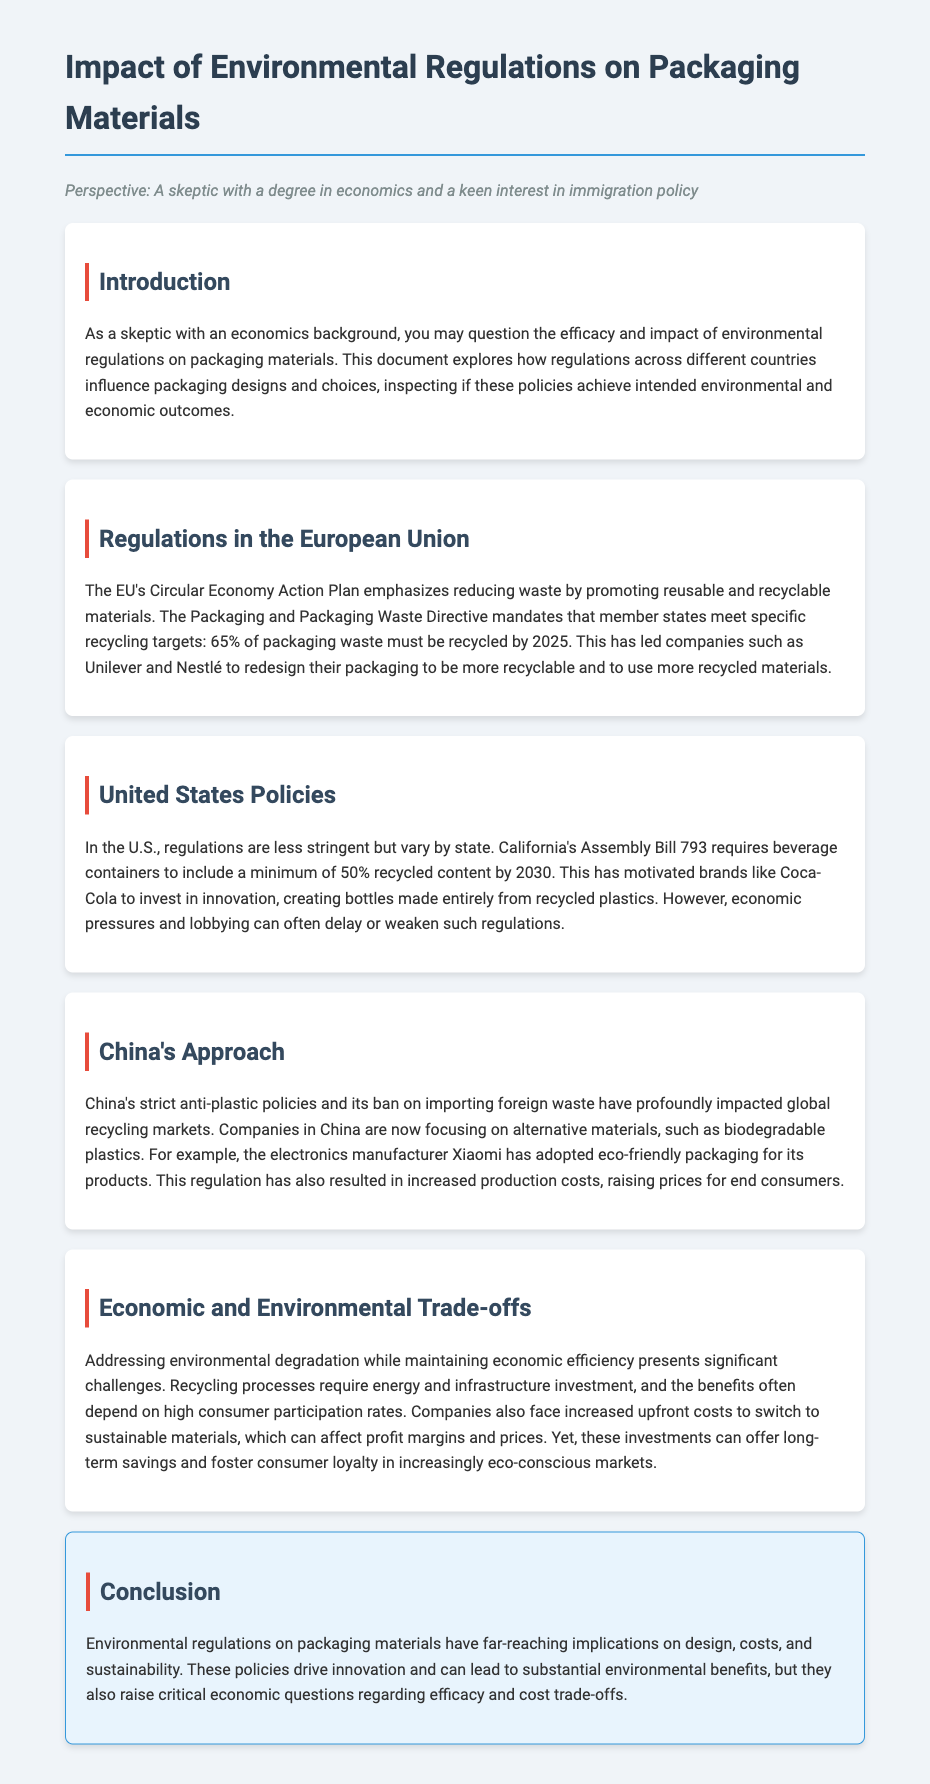What is the main goal of the EU's Circular Economy Action Plan? The goal of the EU's Circular Economy Action Plan is to reduce waste by promoting reusable and recyclable materials.
Answer: Reduce waste What is the recycling target for packaging waste in the EU by 2025? The document states that member states must meet a recycling target of 65% of packaging waste by 2025.
Answer: 65% What legislation in California requires recycled content in beverage containers? The legislation mentioned in the document is California's Assembly Bill 793.
Answer: Assembly Bill 793 Which company has adopted eco-friendly packaging in response to China's policies? The company referenced in the document is Xiaomi.
Answer: Xiaomi What economic challenge is mentioned regarding recycling processes? The document highlights that recycling processes require energy and infrastructure investment.
Answer: Energy and infrastructure investment How do environmental regulations impact companies economically? The document notes that companies face increased upfront costs to switch to sustainable materials.
Answer: Increased upfront costs What innovative investment did Coca-Cola make according to U.S. policies? Coca-Cola invested in creating bottles made entirely from recycled plastics.
Answer: Bottles made entirely from recycled plastics What is one critical question raised regarding the efficacy of environmental regulations? The document raises questions about the cost trade-offs associated with these regulations.
Answer: Cost trade-offs In which section is the conclusion found? The conclusion is provided in its own section titled "Conclusion."
Answer: Conclusion 